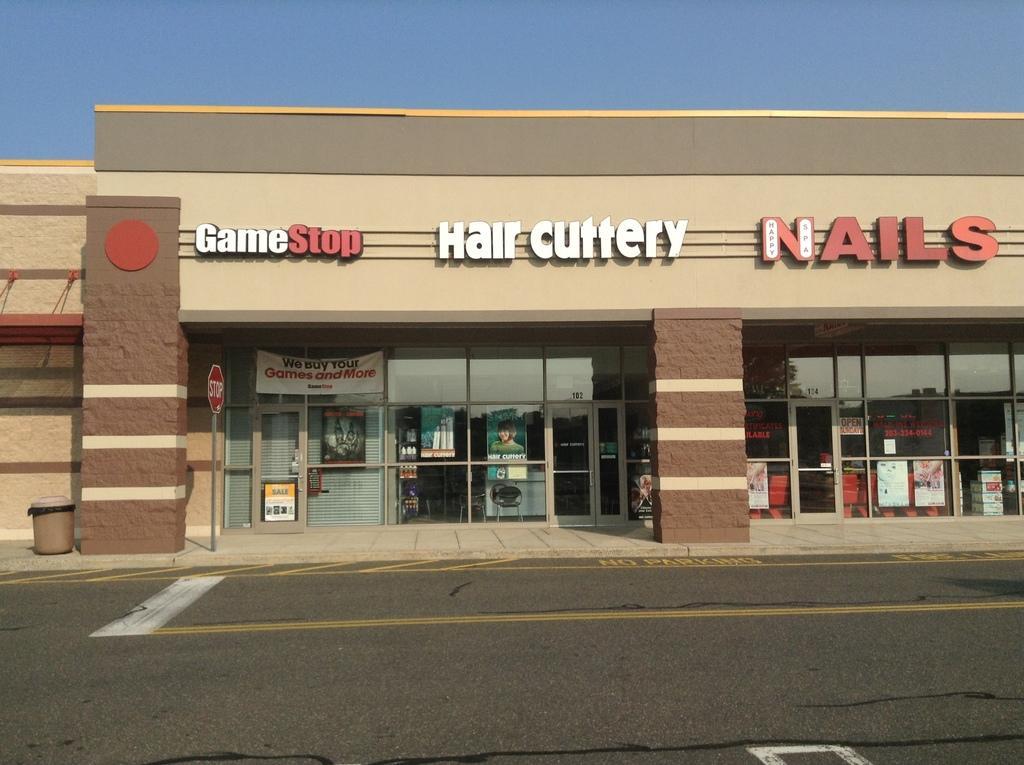Please provide a concise description of this image. In this image we can see the building with the text and there are posters attached to the window. And there are doors and pillars. We can see a sign board and dustbin on the ground. In front of the building we can see a road. In the background, we can see the sky. 